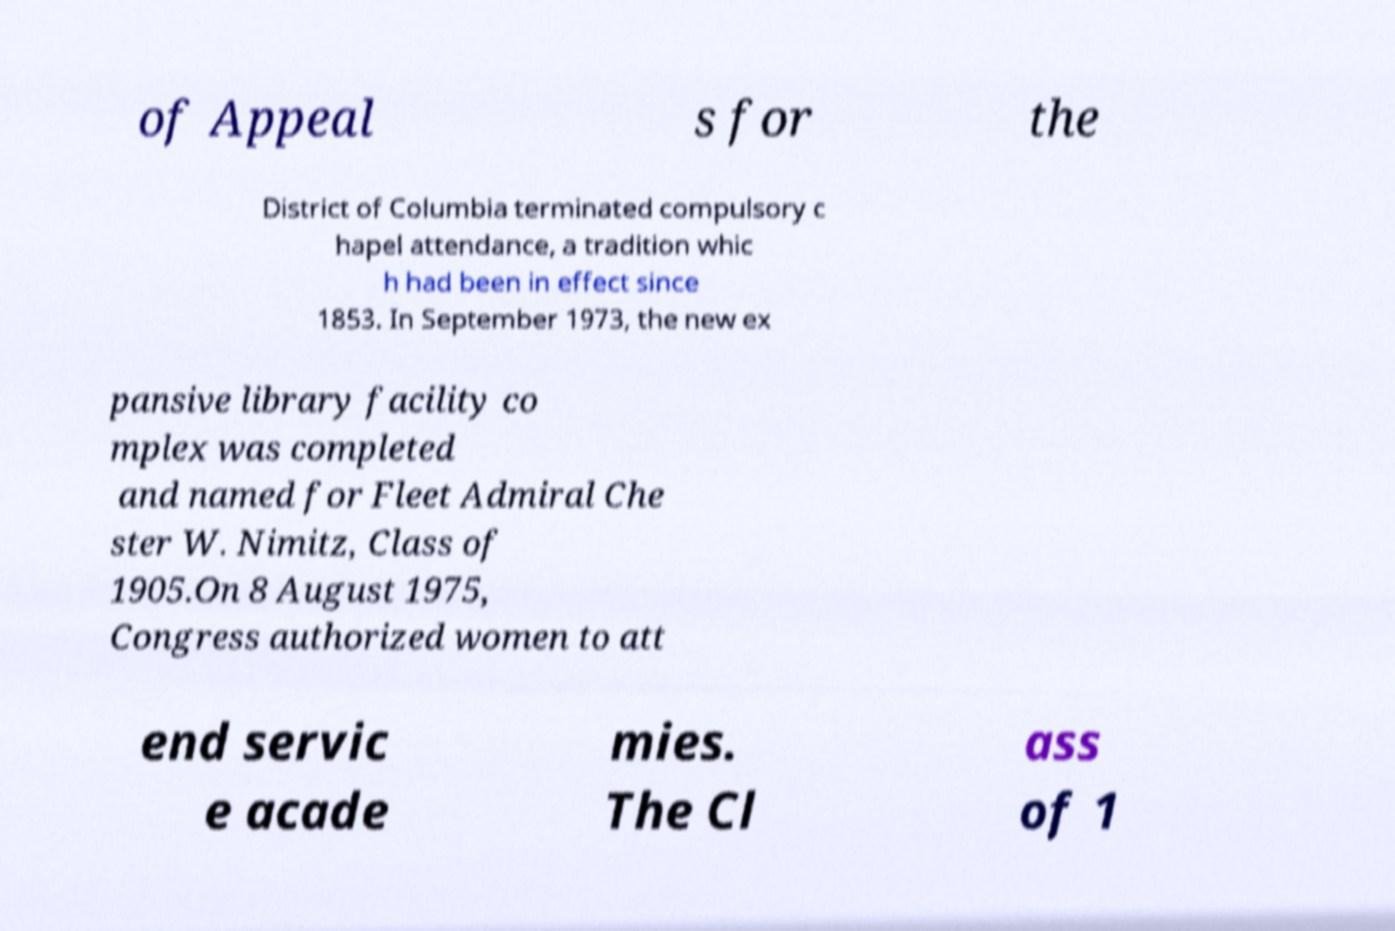For documentation purposes, I need the text within this image transcribed. Could you provide that? of Appeal s for the District of Columbia terminated compulsory c hapel attendance, a tradition whic h had been in effect since 1853. In September 1973, the new ex pansive library facility co mplex was completed and named for Fleet Admiral Che ster W. Nimitz, Class of 1905.On 8 August 1975, Congress authorized women to att end servic e acade mies. The Cl ass of 1 